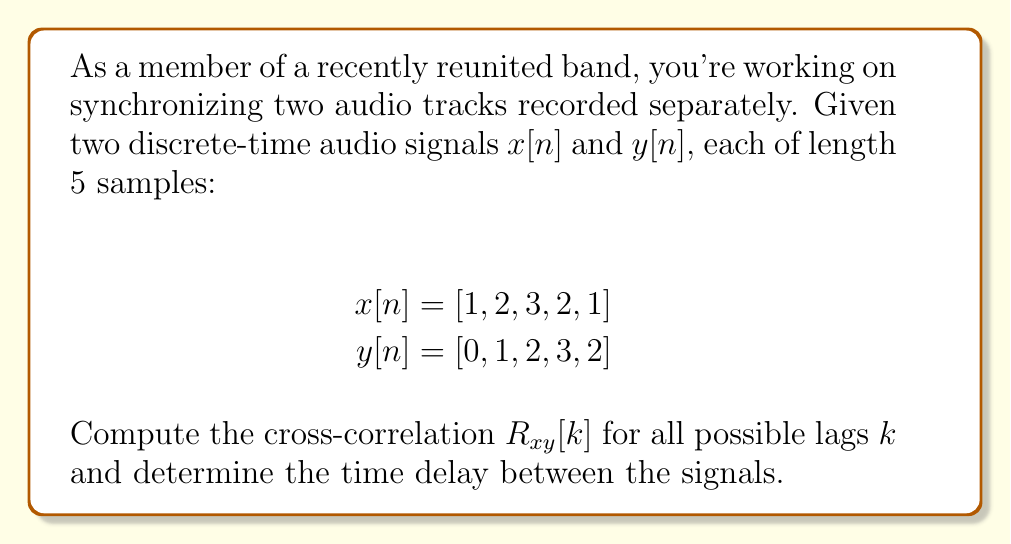Help me with this question. To solve this problem, we'll follow these steps:

1) The cross-correlation $R_{xy}[k]$ is defined as:

   $$R_{xy}[k] = \sum_{n=-\infty}^{\infty} x[n]y[n+k]$$

   For finite signals, we sum over the overlapping region.

2) We need to calculate $R_{xy}[k]$ for $k = -4, -3, -2, -1, 0, 1, 2, 3, 4$:

   For $k = -4$: $R_{xy}[-4] = 1 \cdot 0 = 0$
   For $k = -3$: $R_{xy}[-3] = 1 \cdot 1 + 2 \cdot 0 = 1$
   For $k = -2$: $R_{xy}[-2] = 1 \cdot 2 + 2 \cdot 1 + 3 \cdot 0 = 4$
   For $k = -1$: $R_{xy}[-1] = 1 \cdot 3 + 2 \cdot 2 + 3 \cdot 1 + 2 \cdot 0 = 10$
   For $k = 0$:  $R_{xy}[0] = 1 \cdot 2 + 2 \cdot 3 + 3 \cdot 2 + 2 \cdot 1 + 1 \cdot 0 = 13$
   For $k = 1$:  $R_{xy}[1] = 2 \cdot 2 + 3 \cdot 3 + 2 \cdot 2 + 1 \cdot 1 = 18$
   For $k = 2$:  $R_{xy}[2] = 3 \cdot 3 + 2 \cdot 2 + 1 \cdot 1 = 14$
   For $k = 3$:  $R_{xy}[3] = 2 \cdot 2 + 1 \cdot 1 = 5$
   For $k = 4$:  $R_{xy}[4] = 1 \cdot 1 = 1$

3) The time delay is determined by the lag $k$ that maximizes $R_{xy}[k]$. 

4) The maximum value of $R_{xy}[k]$ occurs at $k = 1$, where $R_{xy}[1] = 18$.

Therefore, the time delay between the signals is 1 sample.
Answer: 1 sample 